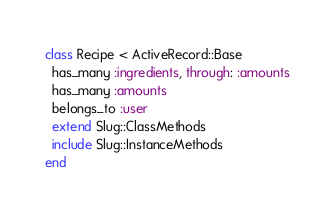Convert code to text. <code><loc_0><loc_0><loc_500><loc_500><_Ruby_>class Recipe < ActiveRecord::Base
  has_many :ingredients, through: :amounts
  has_many :amounts
  belongs_to :user
  extend Slug::ClassMethods
  include Slug::InstanceMethods
end
</code> 